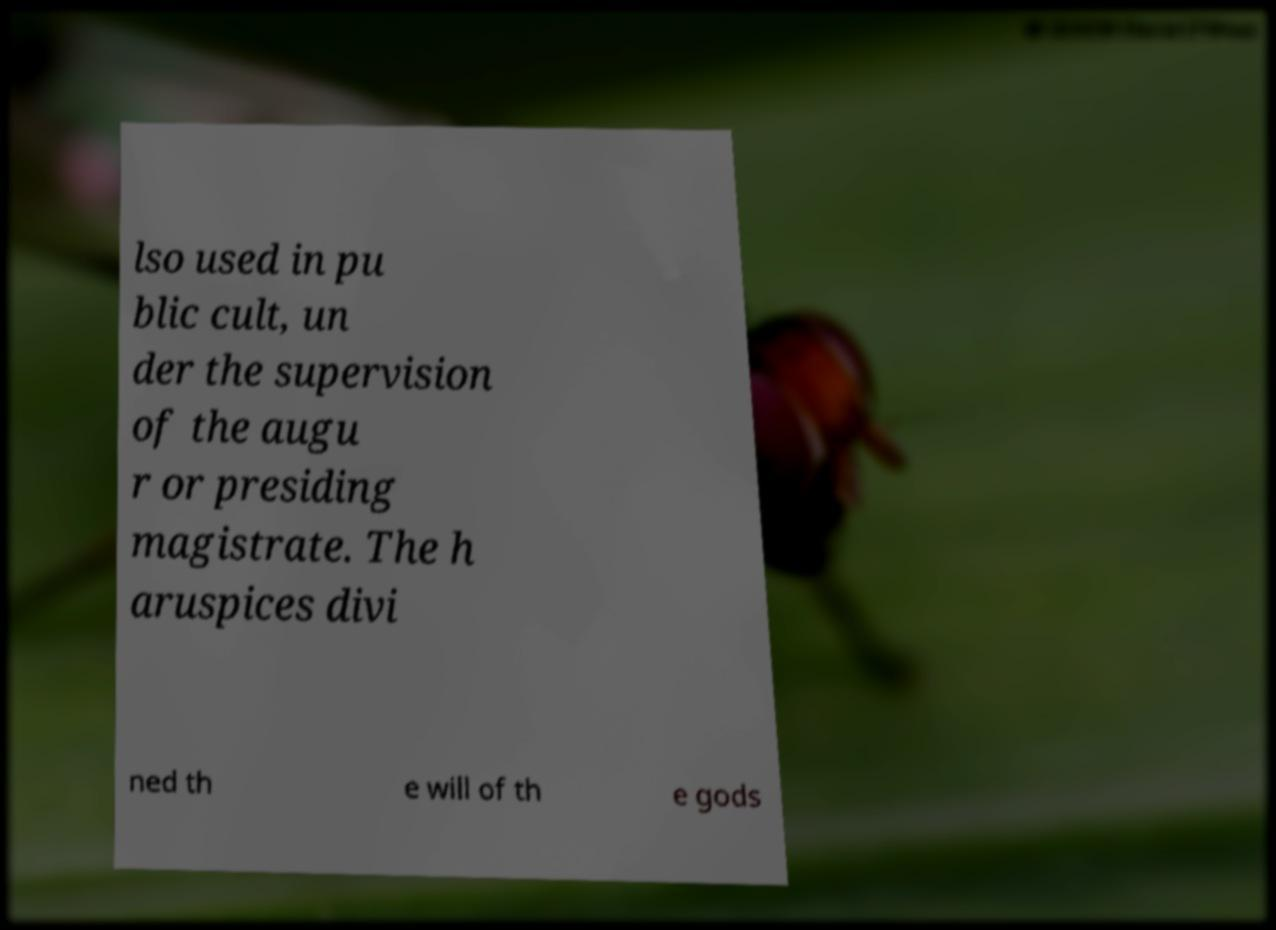Can you read and provide the text displayed in the image?This photo seems to have some interesting text. Can you extract and type it out for me? lso used in pu blic cult, un der the supervision of the augu r or presiding magistrate. The h aruspices divi ned th e will of th e gods 